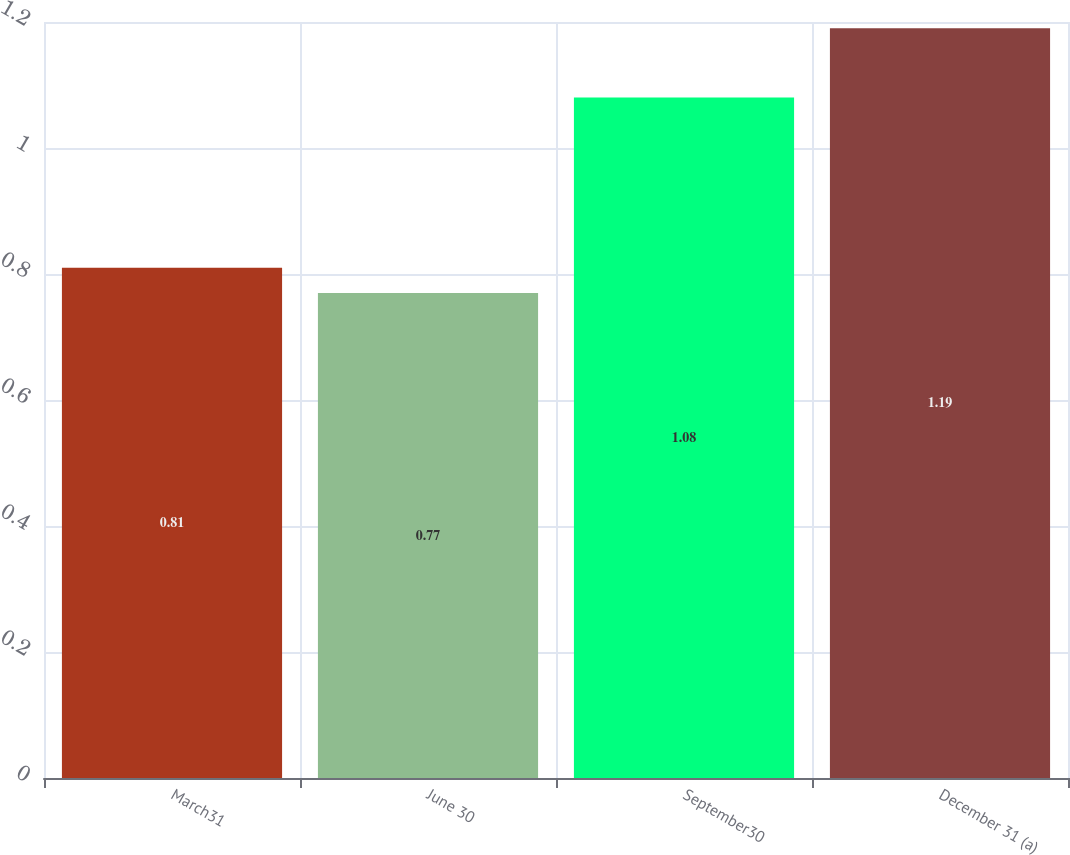<chart> <loc_0><loc_0><loc_500><loc_500><bar_chart><fcel>March31<fcel>June 30<fcel>September30<fcel>December 31 (a)<nl><fcel>0.81<fcel>0.77<fcel>1.08<fcel>1.19<nl></chart> 